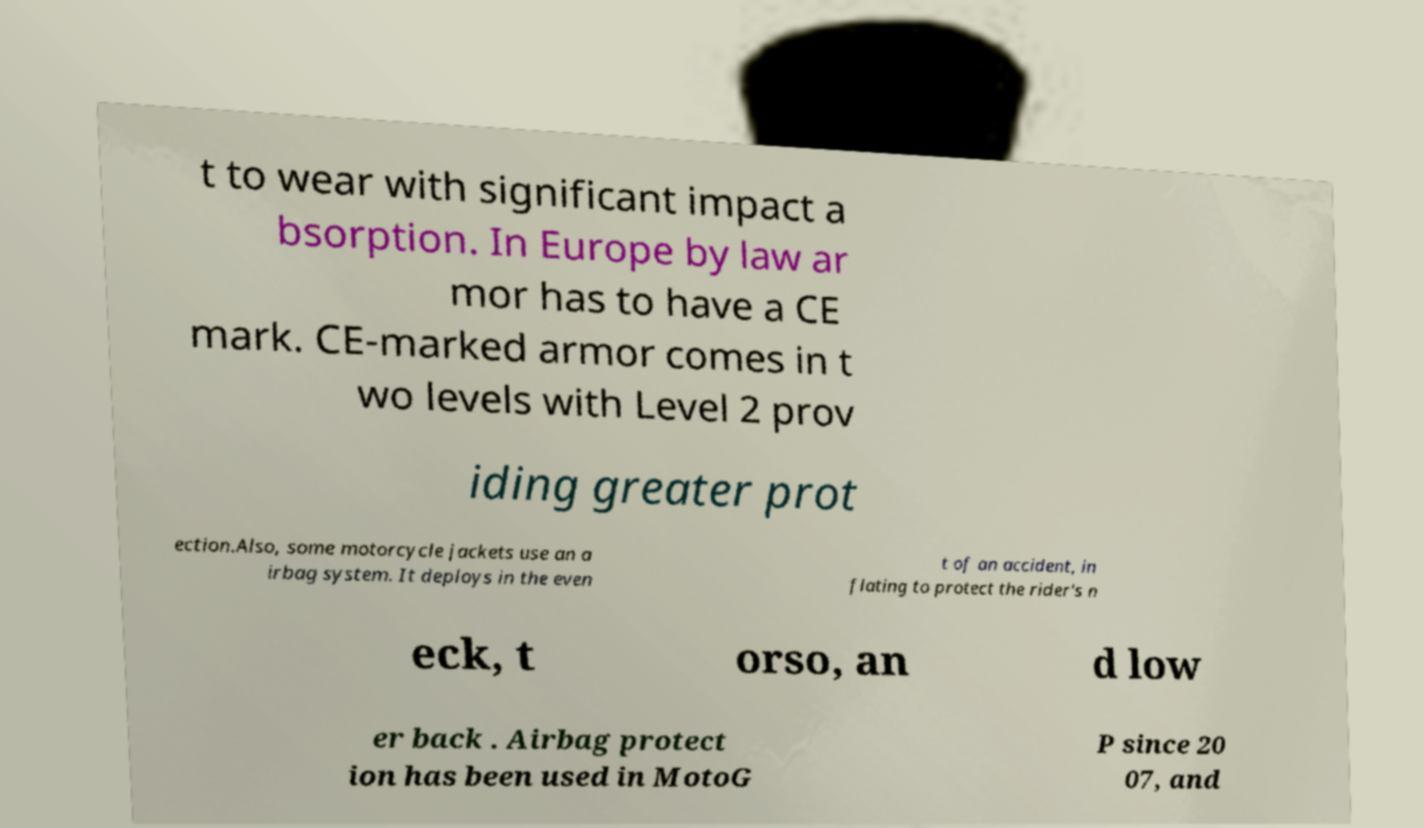For documentation purposes, I need the text within this image transcribed. Could you provide that? t to wear with significant impact a bsorption. In Europe by law ar mor has to have a CE mark. CE-marked armor comes in t wo levels with Level 2 prov iding greater prot ection.Also, some motorcycle jackets use an a irbag system. It deploys in the even t of an accident, in flating to protect the rider's n eck, t orso, an d low er back . Airbag protect ion has been used in MotoG P since 20 07, and 